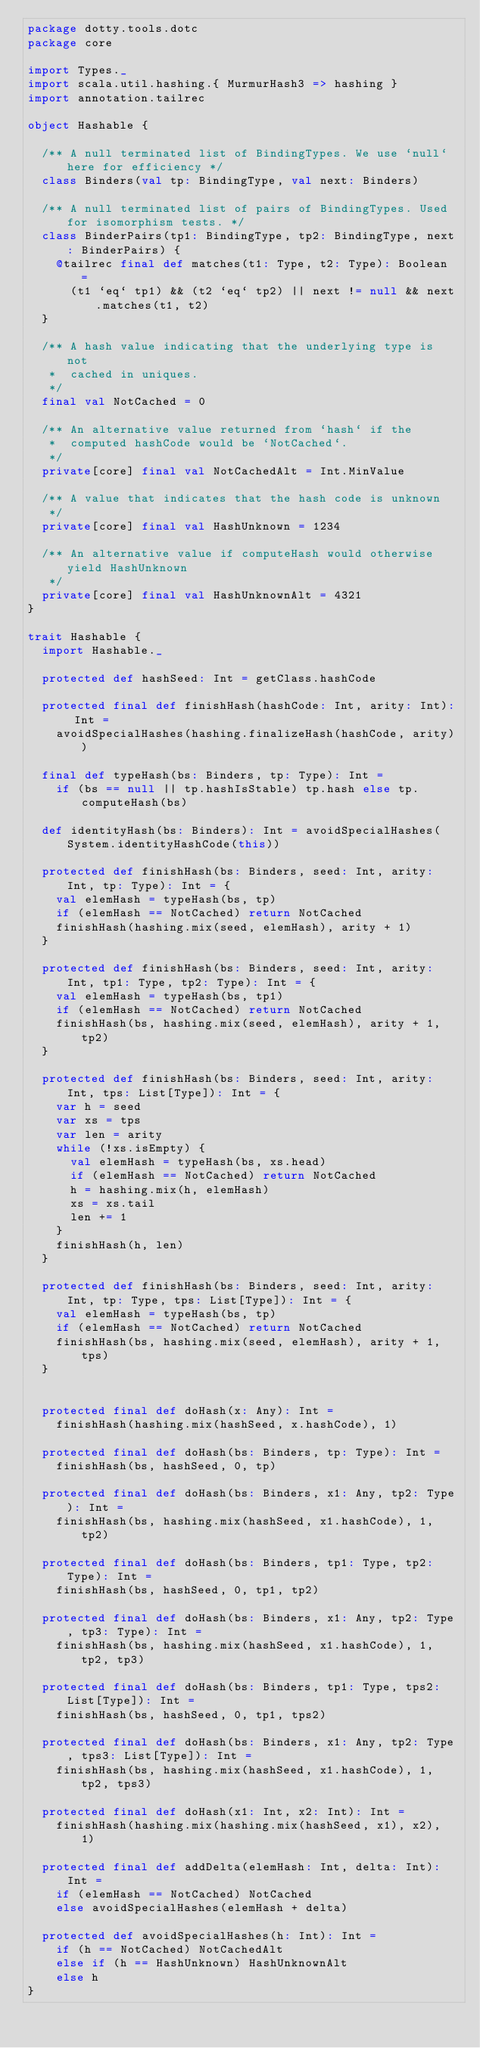<code> <loc_0><loc_0><loc_500><loc_500><_Scala_>package dotty.tools.dotc
package core

import Types._
import scala.util.hashing.{ MurmurHash3 => hashing }
import annotation.tailrec

object Hashable {

  /** A null terminated list of BindingTypes. We use `null` here for efficiency */
  class Binders(val tp: BindingType, val next: Binders)

  /** A null terminated list of pairs of BindingTypes. Used for isomorphism tests. */
  class BinderPairs(tp1: BindingType, tp2: BindingType, next: BinderPairs) {
    @tailrec final def matches(t1: Type, t2: Type): Boolean =
      (t1 `eq` tp1) && (t2 `eq` tp2) || next != null && next.matches(t1, t2)
  }

  /** A hash value indicating that the underlying type is not
   *  cached in uniques.
   */
  final val NotCached = 0

  /** An alternative value returned from `hash` if the
   *  computed hashCode would be `NotCached`.
   */
  private[core] final val NotCachedAlt = Int.MinValue

  /** A value that indicates that the hash code is unknown
   */
  private[core] final val HashUnknown = 1234

  /** An alternative value if computeHash would otherwise yield HashUnknown
   */
  private[core] final val HashUnknownAlt = 4321
}

trait Hashable {
  import Hashable._

  protected def hashSeed: Int = getClass.hashCode

  protected final def finishHash(hashCode: Int, arity: Int): Int =
    avoidSpecialHashes(hashing.finalizeHash(hashCode, arity))

  final def typeHash(bs: Binders, tp: Type): Int =
    if (bs == null || tp.hashIsStable) tp.hash else tp.computeHash(bs)

  def identityHash(bs: Binders): Int = avoidSpecialHashes(System.identityHashCode(this))

  protected def finishHash(bs: Binders, seed: Int, arity: Int, tp: Type): Int = {
    val elemHash = typeHash(bs, tp)
    if (elemHash == NotCached) return NotCached
    finishHash(hashing.mix(seed, elemHash), arity + 1)
  }

  protected def finishHash(bs: Binders, seed: Int, arity: Int, tp1: Type, tp2: Type): Int = {
    val elemHash = typeHash(bs, tp1)
    if (elemHash == NotCached) return NotCached
    finishHash(bs, hashing.mix(seed, elemHash), arity + 1, tp2)
  }

  protected def finishHash(bs: Binders, seed: Int, arity: Int, tps: List[Type]): Int = {
    var h = seed
    var xs = tps
    var len = arity
    while (!xs.isEmpty) {
      val elemHash = typeHash(bs, xs.head)
      if (elemHash == NotCached) return NotCached
      h = hashing.mix(h, elemHash)
      xs = xs.tail
      len += 1
    }
    finishHash(h, len)
  }

  protected def finishHash(bs: Binders, seed: Int, arity: Int, tp: Type, tps: List[Type]): Int = {
    val elemHash = typeHash(bs, tp)
    if (elemHash == NotCached) return NotCached
    finishHash(bs, hashing.mix(seed, elemHash), arity + 1, tps)
  }


  protected final def doHash(x: Any): Int =
    finishHash(hashing.mix(hashSeed, x.hashCode), 1)

  protected final def doHash(bs: Binders, tp: Type): Int =
    finishHash(bs, hashSeed, 0, tp)

  protected final def doHash(bs: Binders, x1: Any, tp2: Type): Int =
    finishHash(bs, hashing.mix(hashSeed, x1.hashCode), 1, tp2)

  protected final def doHash(bs: Binders, tp1: Type, tp2: Type): Int =
    finishHash(bs, hashSeed, 0, tp1, tp2)

  protected final def doHash(bs: Binders, x1: Any, tp2: Type, tp3: Type): Int =
    finishHash(bs, hashing.mix(hashSeed, x1.hashCode), 1, tp2, tp3)

  protected final def doHash(bs: Binders, tp1: Type, tps2: List[Type]): Int =
    finishHash(bs, hashSeed, 0, tp1, tps2)

  protected final def doHash(bs: Binders, x1: Any, tp2: Type, tps3: List[Type]): Int =
    finishHash(bs, hashing.mix(hashSeed, x1.hashCode), 1, tp2, tps3)

  protected final def doHash(x1: Int, x2: Int): Int =
    finishHash(hashing.mix(hashing.mix(hashSeed, x1), x2), 1)

  protected final def addDelta(elemHash: Int, delta: Int): Int =
    if (elemHash == NotCached) NotCached
    else avoidSpecialHashes(elemHash + delta)

  protected def avoidSpecialHashes(h: Int): Int =
    if (h == NotCached) NotCachedAlt
    else if (h == HashUnknown) HashUnknownAlt
    else h
}
</code> 